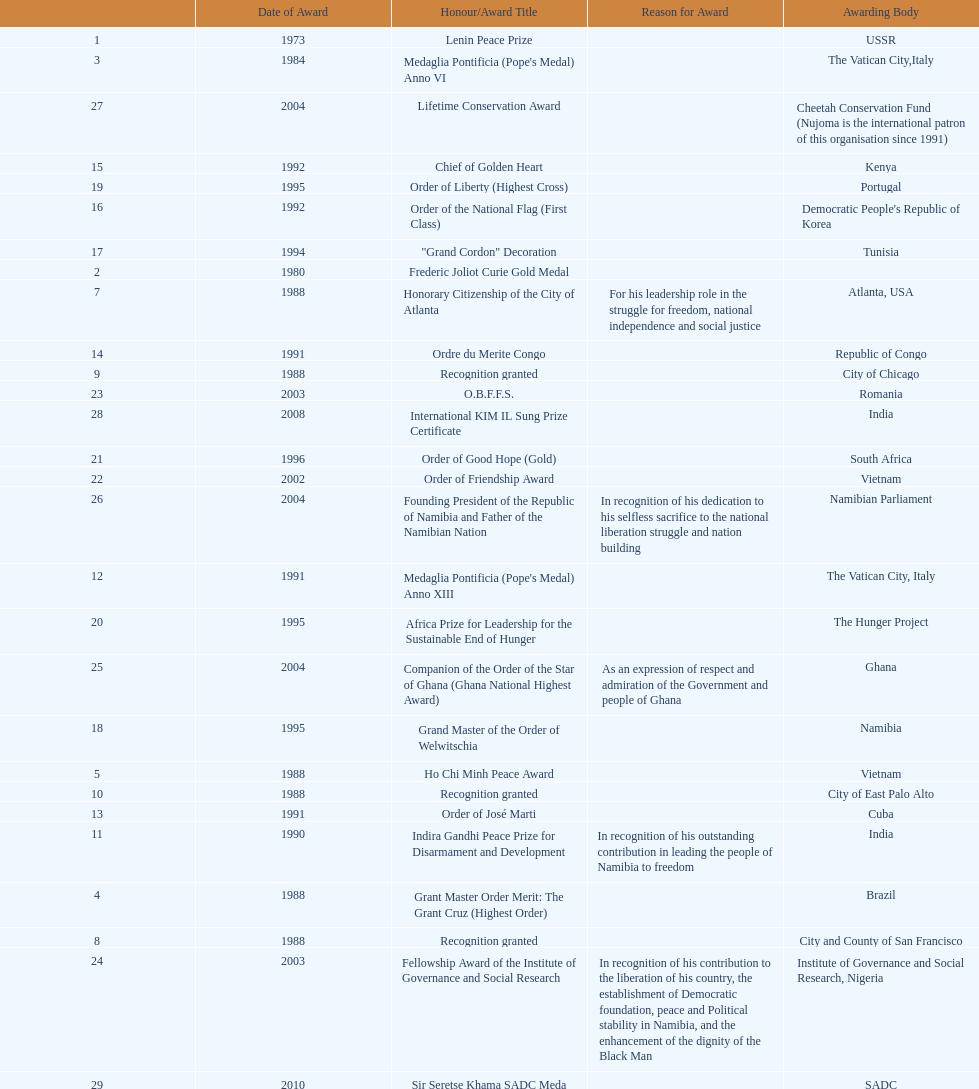What was the most recent award nujoma received? Sir Seretse Khama SADC Meda. 